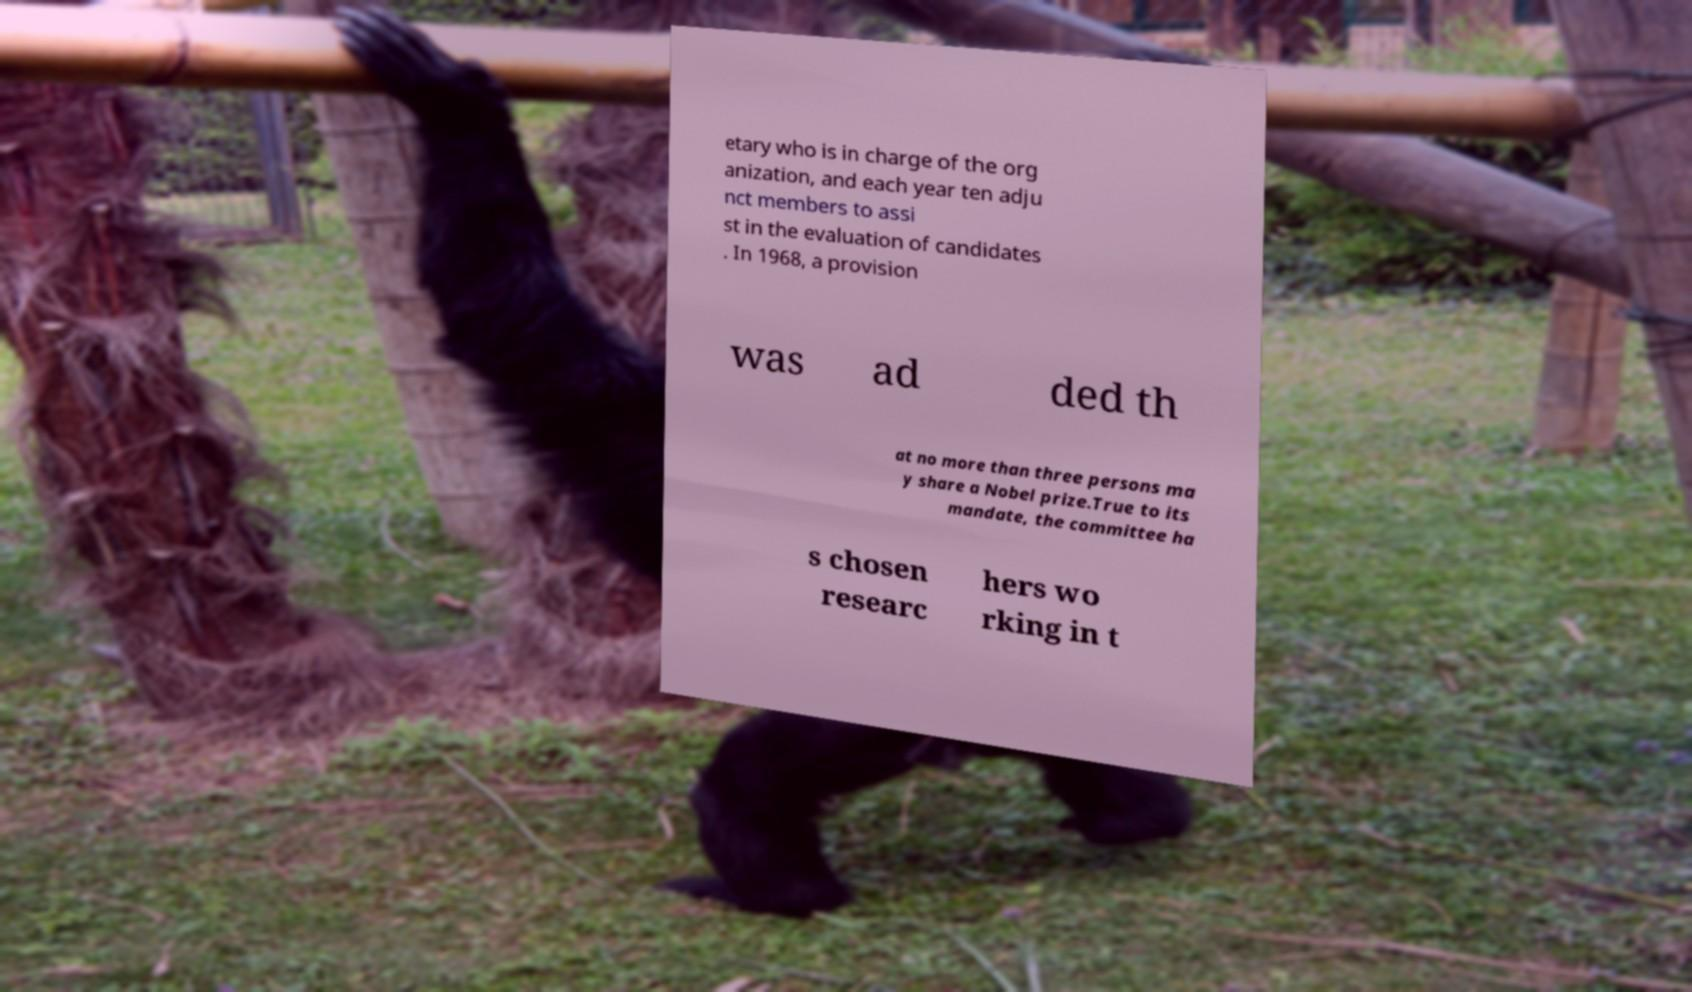Can you read and provide the text displayed in the image?This photo seems to have some interesting text. Can you extract and type it out for me? etary who is in charge of the org anization, and each year ten adju nct members to assi st in the evaluation of candidates . In 1968, a provision was ad ded th at no more than three persons ma y share a Nobel prize.True to its mandate, the committee ha s chosen researc hers wo rking in t 